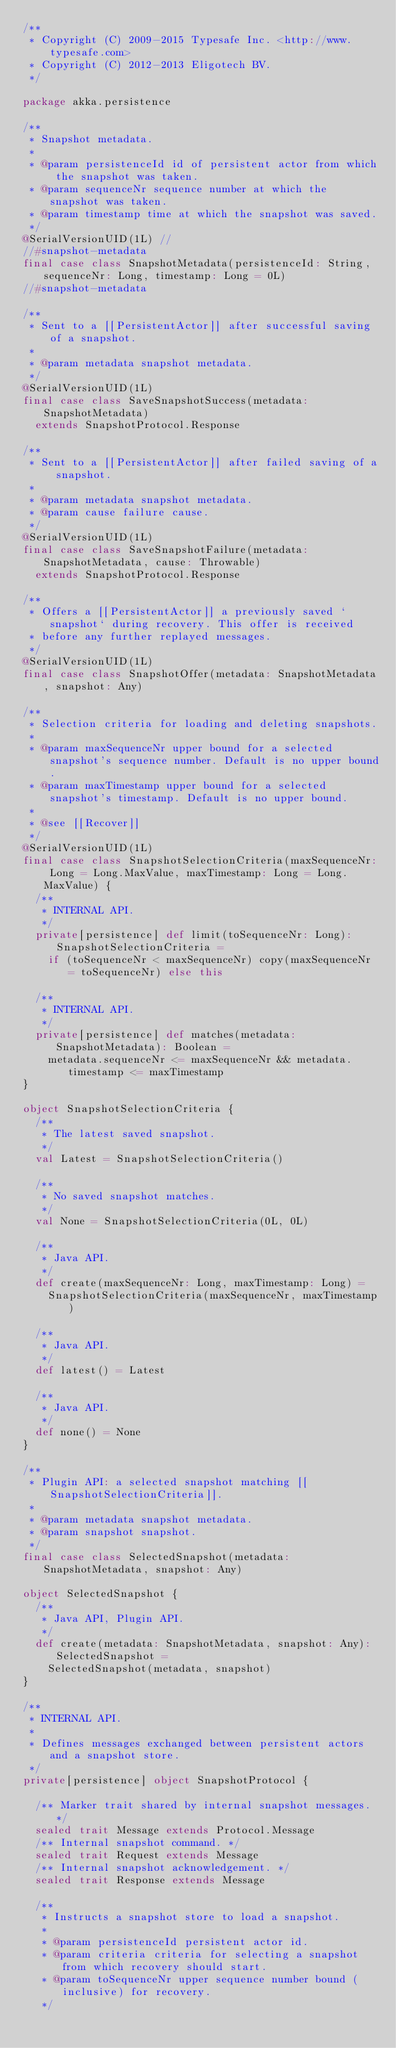Convert code to text. <code><loc_0><loc_0><loc_500><loc_500><_Scala_>/**
 * Copyright (C) 2009-2015 Typesafe Inc. <http://www.typesafe.com>
 * Copyright (C) 2012-2013 Eligotech BV.
 */

package akka.persistence

/**
 * Snapshot metadata.
 *
 * @param persistenceId id of persistent actor from which the snapshot was taken.
 * @param sequenceNr sequence number at which the snapshot was taken.
 * @param timestamp time at which the snapshot was saved.
 */
@SerialVersionUID(1L) //
//#snapshot-metadata
final case class SnapshotMetadata(persistenceId: String, sequenceNr: Long, timestamp: Long = 0L)
//#snapshot-metadata

/**
 * Sent to a [[PersistentActor]] after successful saving of a snapshot.
 *
 * @param metadata snapshot metadata.
 */
@SerialVersionUID(1L)
final case class SaveSnapshotSuccess(metadata: SnapshotMetadata)
  extends SnapshotProtocol.Response

/**
 * Sent to a [[PersistentActor]] after failed saving of a snapshot.
 *
 * @param metadata snapshot metadata.
 * @param cause failure cause.
 */
@SerialVersionUID(1L)
final case class SaveSnapshotFailure(metadata: SnapshotMetadata, cause: Throwable)
  extends SnapshotProtocol.Response

/**
 * Offers a [[PersistentActor]] a previously saved `snapshot` during recovery. This offer is received
 * before any further replayed messages.
 */
@SerialVersionUID(1L)
final case class SnapshotOffer(metadata: SnapshotMetadata, snapshot: Any)

/**
 * Selection criteria for loading and deleting snapshots.
 *
 * @param maxSequenceNr upper bound for a selected snapshot's sequence number. Default is no upper bound.
 * @param maxTimestamp upper bound for a selected snapshot's timestamp. Default is no upper bound.
 *
 * @see [[Recover]]
 */
@SerialVersionUID(1L)
final case class SnapshotSelectionCriteria(maxSequenceNr: Long = Long.MaxValue, maxTimestamp: Long = Long.MaxValue) {
  /**
   * INTERNAL API.
   */
  private[persistence] def limit(toSequenceNr: Long): SnapshotSelectionCriteria =
    if (toSequenceNr < maxSequenceNr) copy(maxSequenceNr = toSequenceNr) else this

  /**
   * INTERNAL API.
   */
  private[persistence] def matches(metadata: SnapshotMetadata): Boolean =
    metadata.sequenceNr <= maxSequenceNr && metadata.timestamp <= maxTimestamp
}

object SnapshotSelectionCriteria {
  /**
   * The latest saved snapshot.
   */
  val Latest = SnapshotSelectionCriteria()

  /**
   * No saved snapshot matches.
   */
  val None = SnapshotSelectionCriteria(0L, 0L)

  /**
   * Java API.
   */
  def create(maxSequenceNr: Long, maxTimestamp: Long) =
    SnapshotSelectionCriteria(maxSequenceNr, maxTimestamp)

  /**
   * Java API.
   */
  def latest() = Latest

  /**
   * Java API.
   */
  def none() = None
}

/**
 * Plugin API: a selected snapshot matching [[SnapshotSelectionCriteria]].
 *
 * @param metadata snapshot metadata.
 * @param snapshot snapshot.
 */
final case class SelectedSnapshot(metadata: SnapshotMetadata, snapshot: Any)

object SelectedSnapshot {
  /**
   * Java API, Plugin API.
   */
  def create(metadata: SnapshotMetadata, snapshot: Any): SelectedSnapshot =
    SelectedSnapshot(metadata, snapshot)
}

/**
 * INTERNAL API.
 *
 * Defines messages exchanged between persistent actors and a snapshot store.
 */
private[persistence] object SnapshotProtocol {

  /** Marker trait shared by internal snapshot messages. */
  sealed trait Message extends Protocol.Message
  /** Internal snapshot command. */
  sealed trait Request extends Message
  /** Internal snapshot acknowledgement. */
  sealed trait Response extends Message

  /**
   * Instructs a snapshot store to load a snapshot.
   *
   * @param persistenceId persistent actor id.
   * @param criteria criteria for selecting a snapshot from which recovery should start.
   * @param toSequenceNr upper sequence number bound (inclusive) for recovery.
   */</code> 